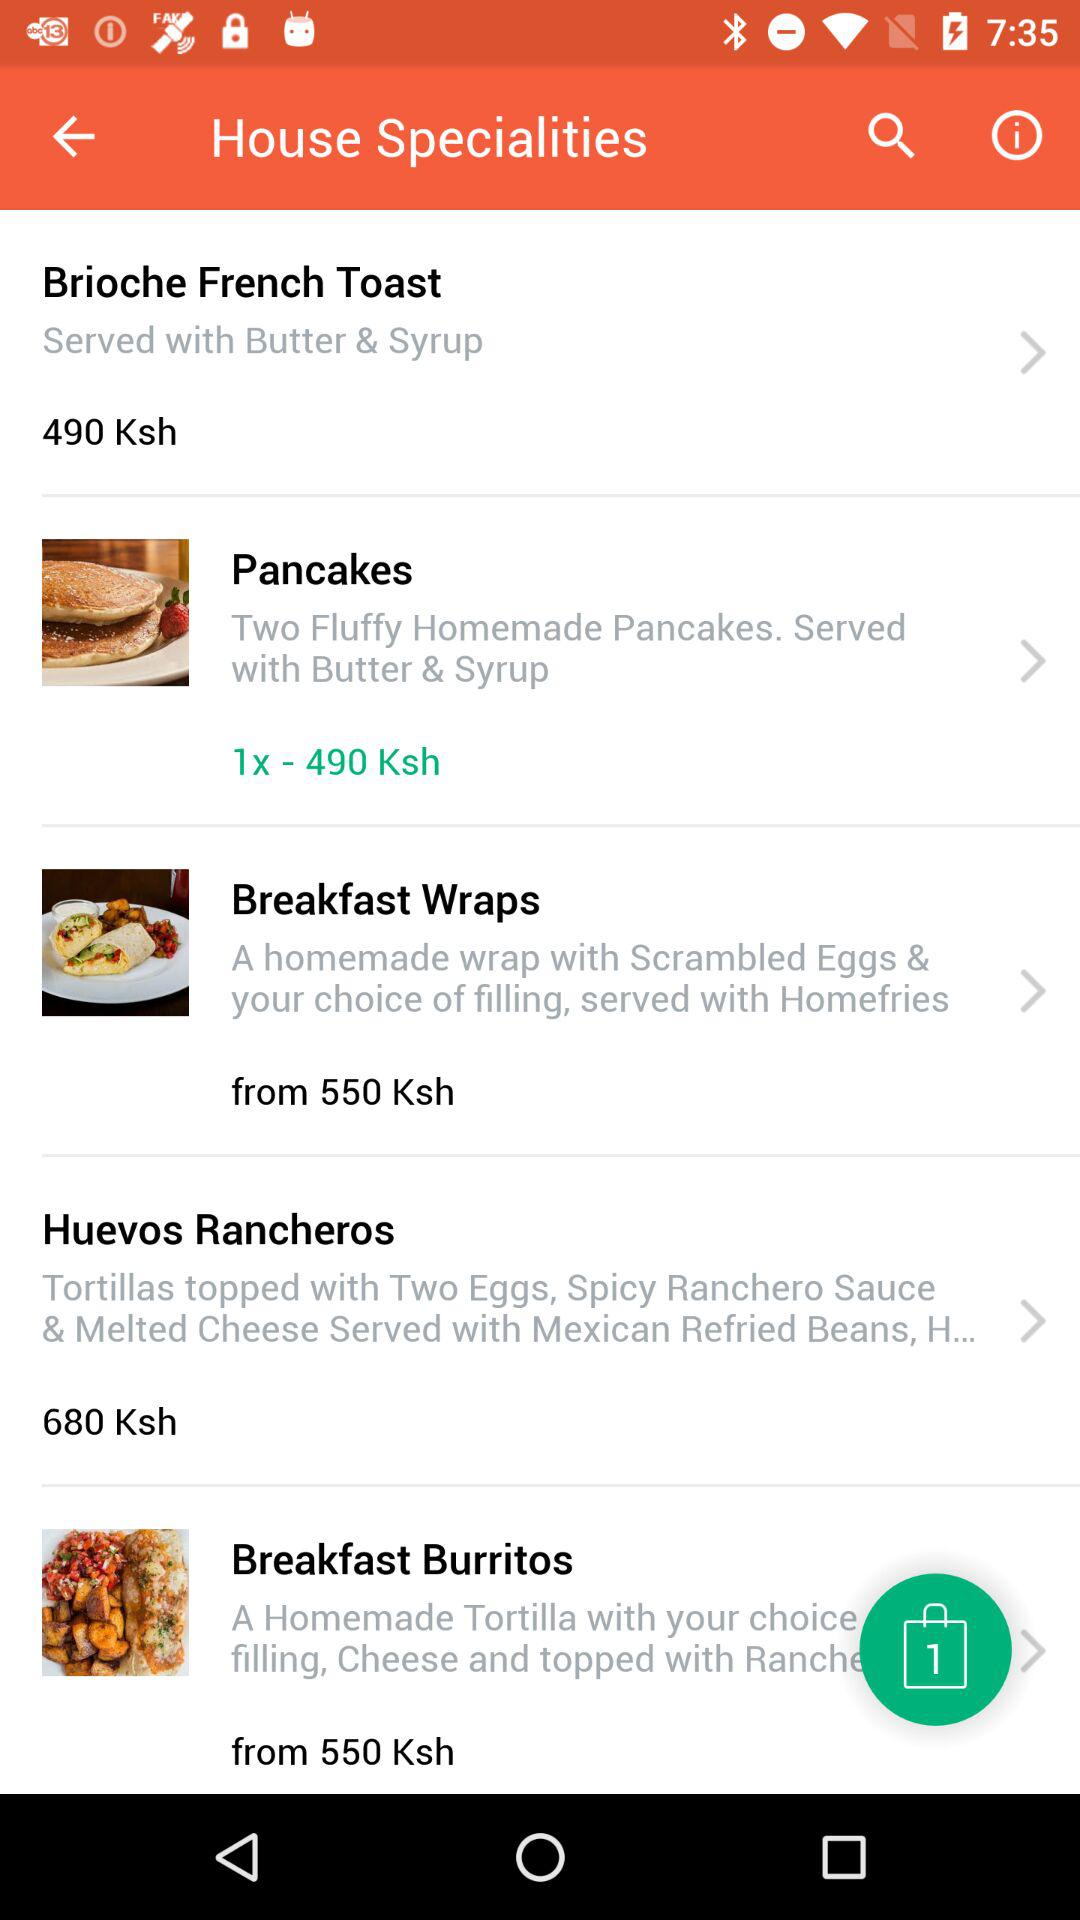What is the price of the pancakes? The price of the pancakes is 490 Ksh. 